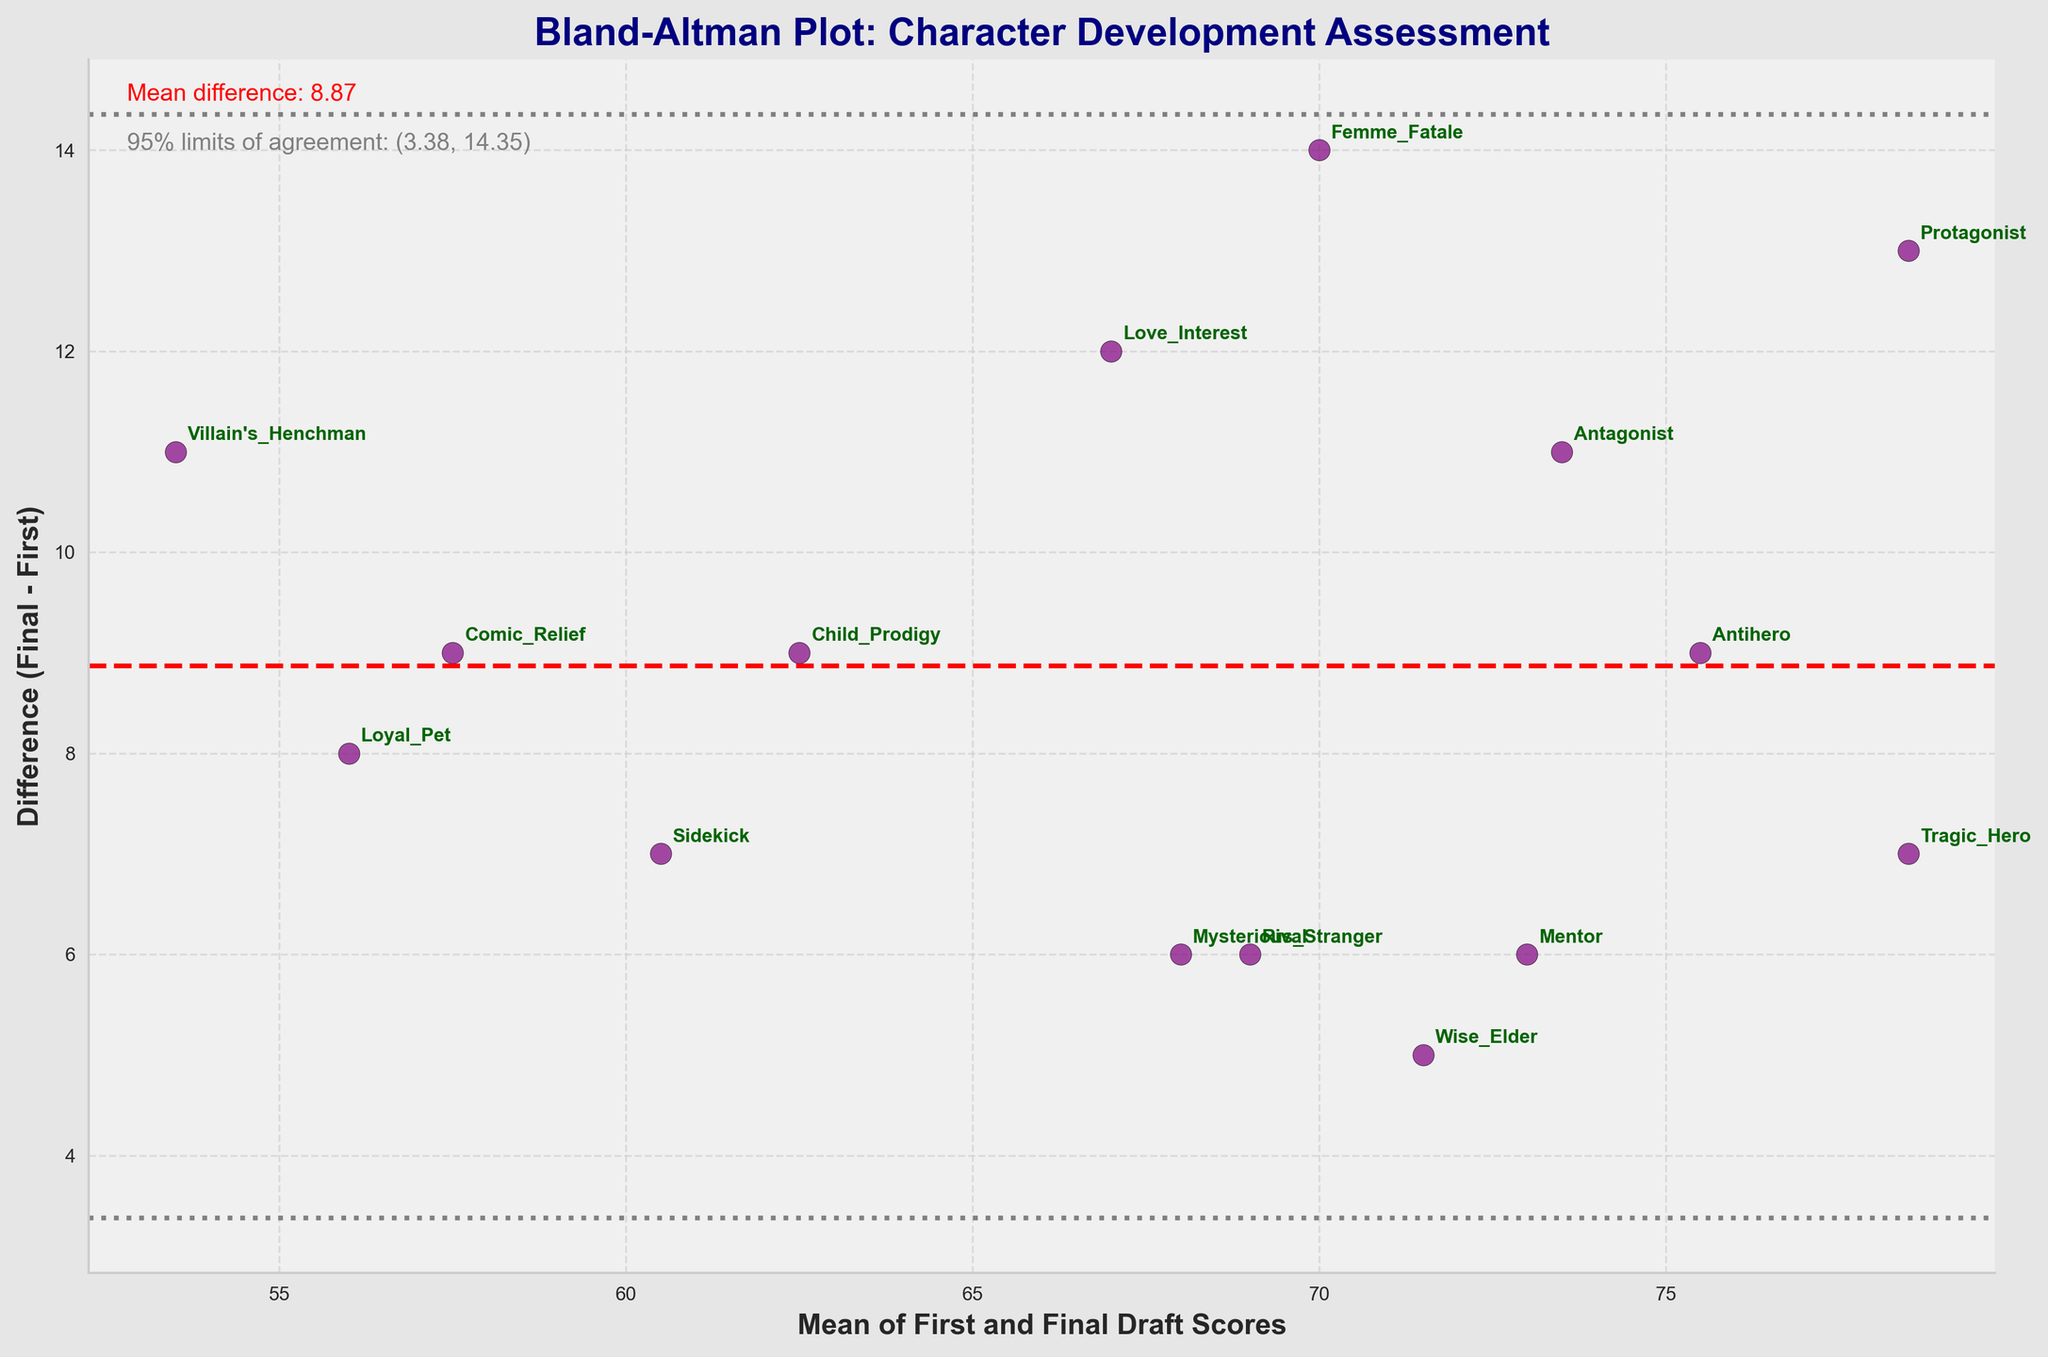What is the title of the plot? The title of the plot is located at the top and is often the most prominent text. It provides an overall description of what the plot represents.
Answer: Bland-Altman Plot: Character Development Assessment How many characters are evaluated in the plot? By counting the individual data points or the labeled characters on the plot, we can determine the number of characters assessed.
Answer: 15 What is the mean difference between first and final draft scores for the characters? The mean difference is often indicated by a horizontal dashed line (usually in red) on a Bland–Altman plot with an accompanying text label.
Answer: Approximately 10.47 What is the difference in scores for the "Tragic_Hero" character? Locate the "Tragic_Hero" label on the plot, then check its corresponding difference on the vertical axis.
Answer: 7 Which character shows the greatest improvement from the first to the final draft? Identify which point on the plot has the highest positive difference (where final draft score is much higher than the first draft score).
Answer: Protagonist What is shown by the two gray dashed lines above and below the mean difference? These lines represent the 95% limits of agreement. They are typically drawn at mean difference ± 1.96 times the standard deviation of the differences.
Answer: 95% limits of agreement Which character has the lowest mean score between first and final drafts? Calculate the mean of the first and final draft scores for each character and then identify the lowest mean. Alternatively, locate the leftmost point on the horizontal axis.
Answer: Villain's Henchman What are the 95% limits of agreement given in the plot? These values are usually displayed as text on the plot or can be inferred from the positions of the horizontal gray dashed lines. They are calculated by taking the mean difference and adding/subtracting 1.96 times the standard deviation of the differences.
Answer: (-0.89, 21.82) Which two characters have the smallest difference between their first and final draft scores? Locate the data points that are closest to the horizontal dashed line representing the mean difference. Look for ones that lie closest to zero on the vertical axis.
Answer: Wise Elder and Mysterious Stranger Who are the characters with a mean score of approximately 72 between the first and final drafts? Points on the horizontal axis around the value of 72 should be identified and their corresponding character labels read.
Answer: Wise Elder, Antihero, Rival 